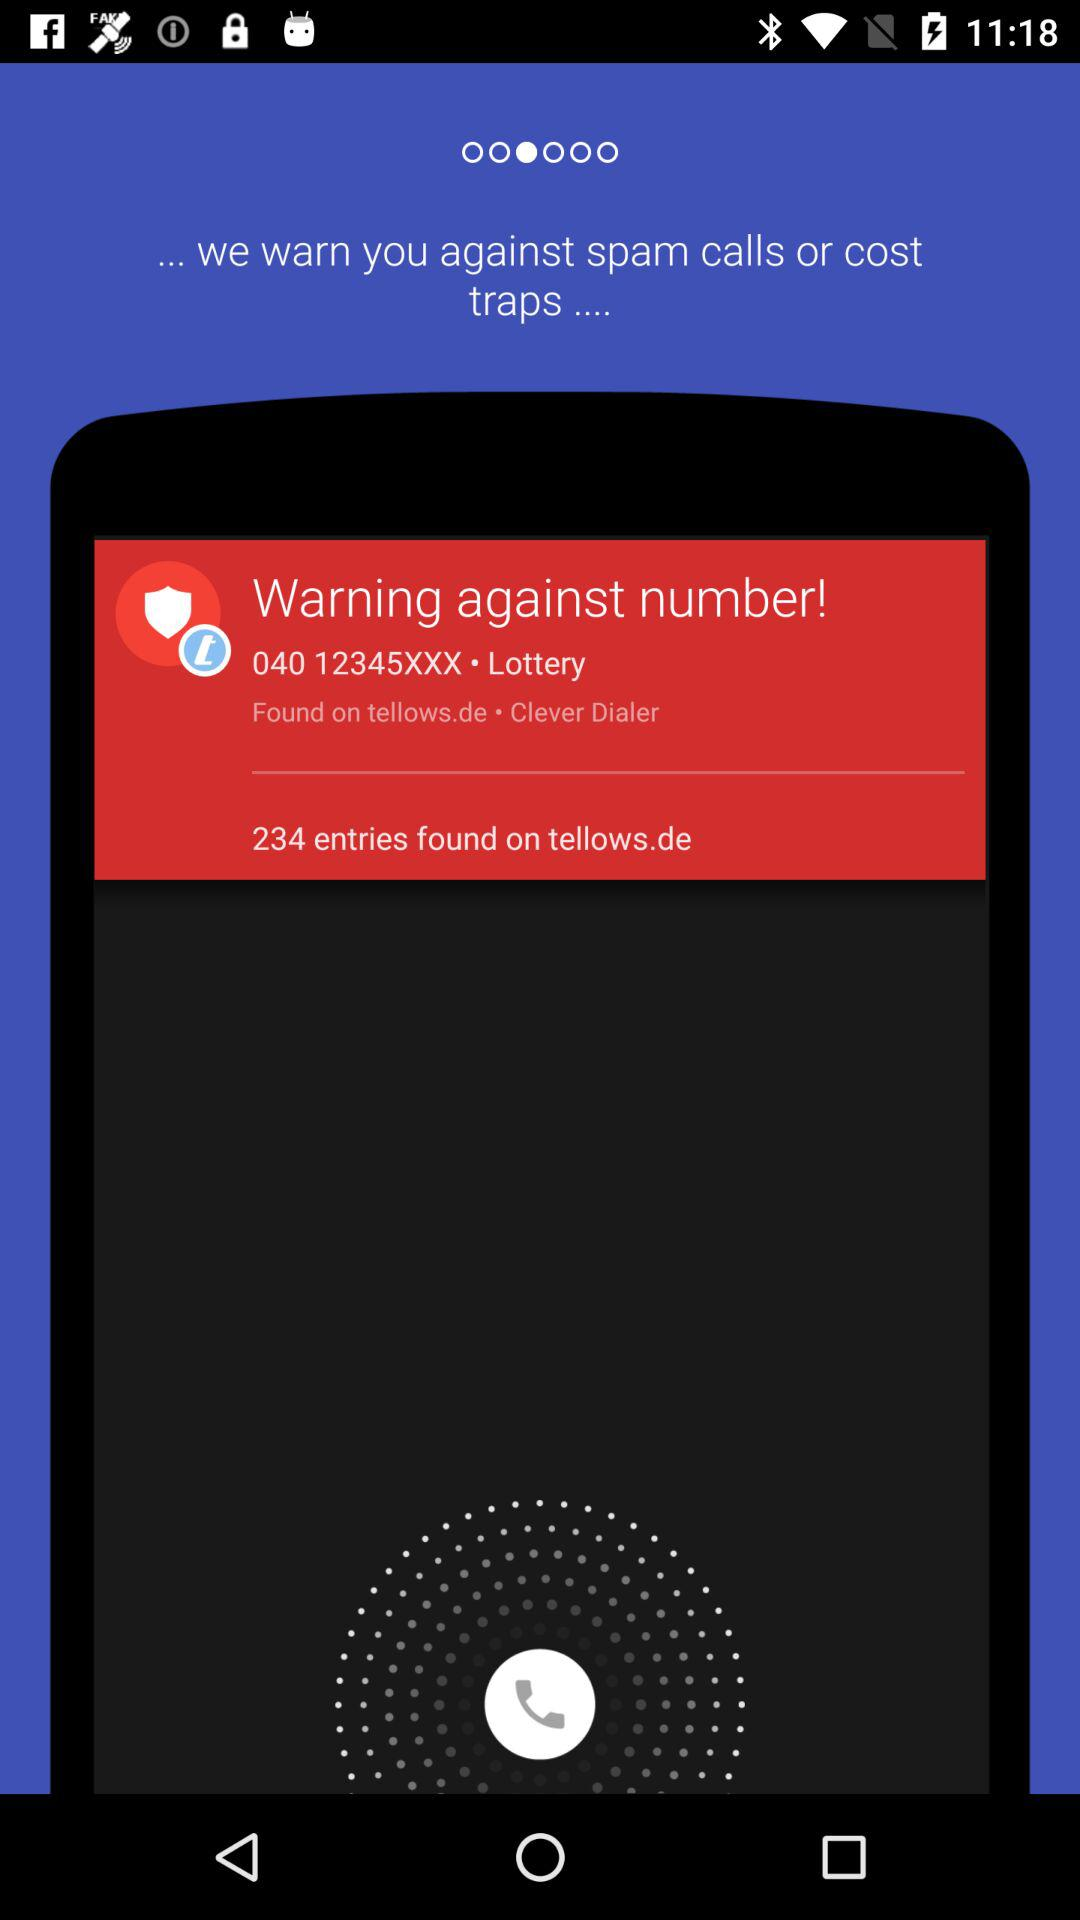What is the number against which the warning has been issued? The number is 040 12345XXX. 